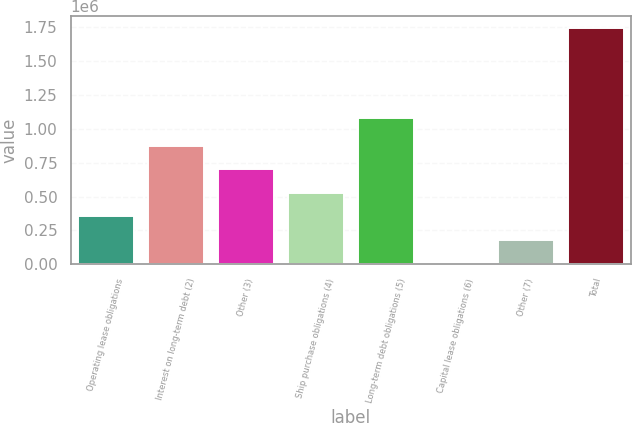Convert chart. <chart><loc_0><loc_0><loc_500><loc_500><bar_chart><fcel>Operating lease obligations<fcel>Interest on long-term debt (2)<fcel>Other (3)<fcel>Ship purchase obligations (4)<fcel>Long-term debt obligations (5)<fcel>Capital lease obligations (6)<fcel>Other (7)<fcel>Total<nl><fcel>354823<fcel>876534<fcel>702631<fcel>528727<fcel>1.07872e+06<fcel>7016<fcel>180920<fcel>1.74605e+06<nl></chart> 